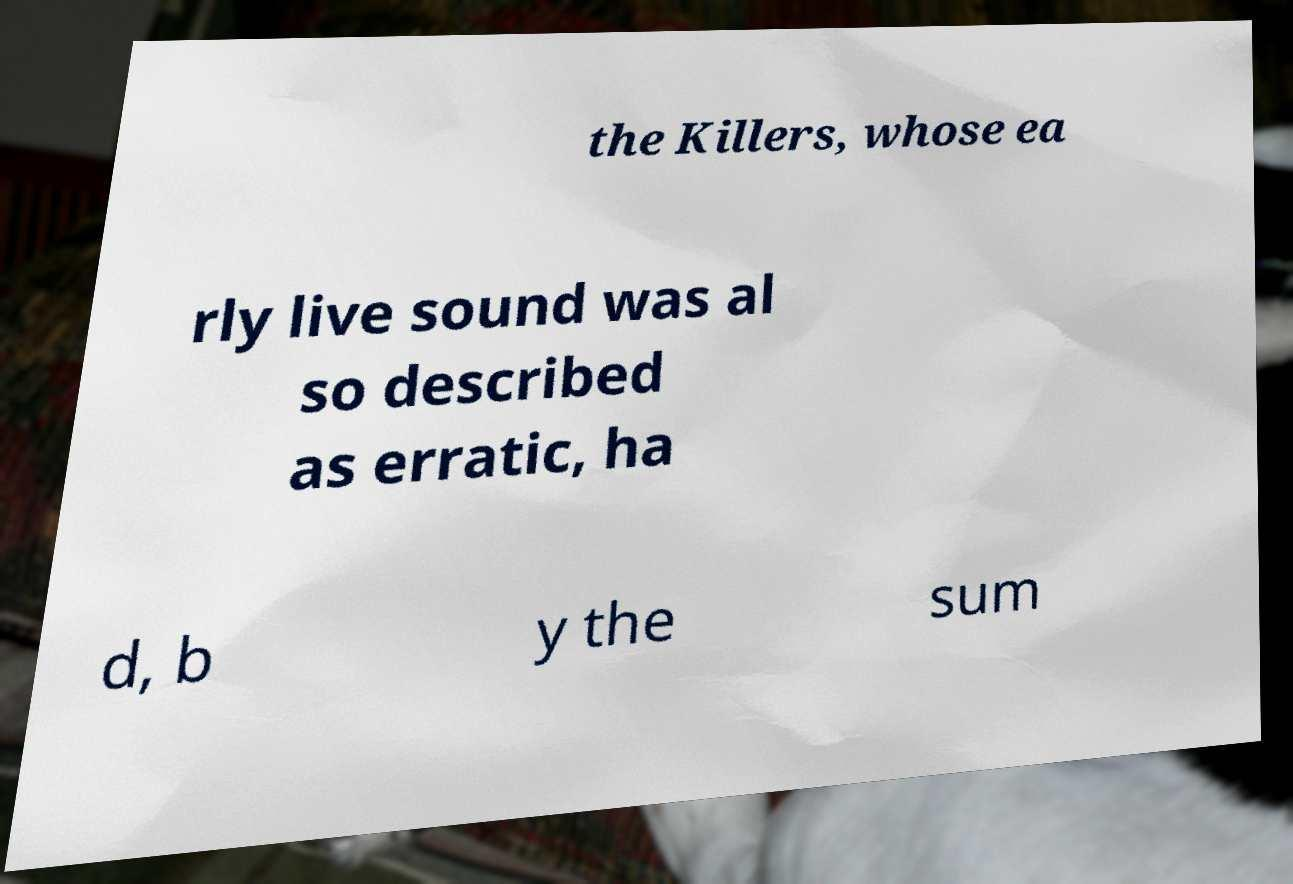Please read and relay the text visible in this image. What does it say? the Killers, whose ea rly live sound was al so described as erratic, ha d, b y the sum 